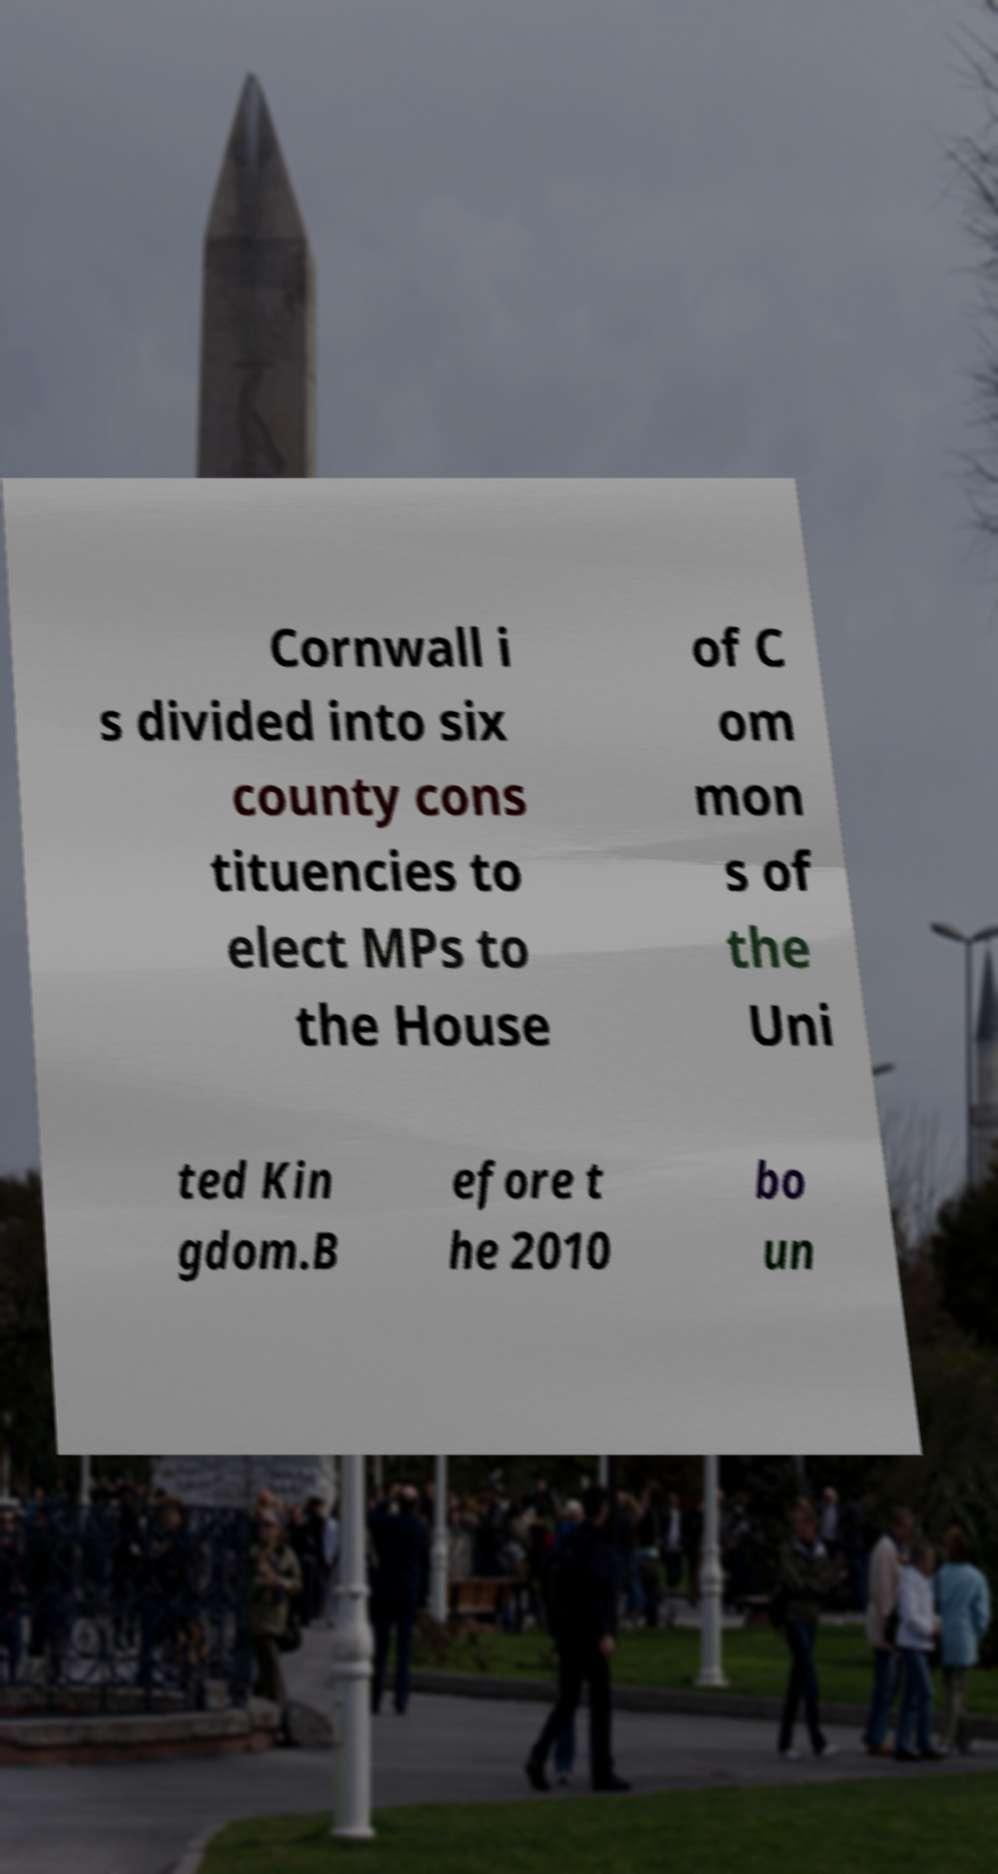There's text embedded in this image that I need extracted. Can you transcribe it verbatim? Cornwall i s divided into six county cons tituencies to elect MPs to the House of C om mon s of the Uni ted Kin gdom.B efore t he 2010 bo un 